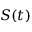<formula> <loc_0><loc_0><loc_500><loc_500>S ( t )</formula> 